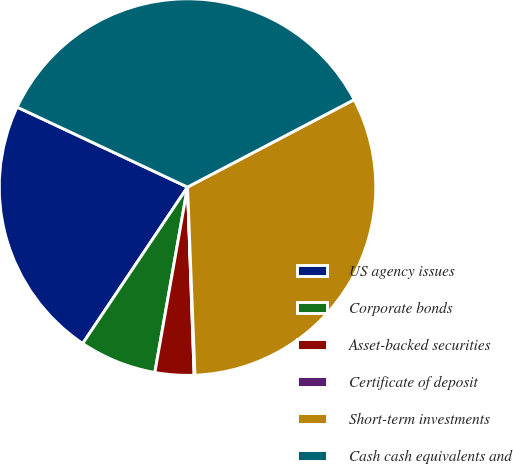Convert chart. <chart><loc_0><loc_0><loc_500><loc_500><pie_chart><fcel>US agency issues<fcel>Corporate bonds<fcel>Asset-backed securities<fcel>Certificate of deposit<fcel>Short-term investments<fcel>Cash cash equivalents and<nl><fcel>22.59%<fcel>6.62%<fcel>3.34%<fcel>0.07%<fcel>32.06%<fcel>35.33%<nl></chart> 